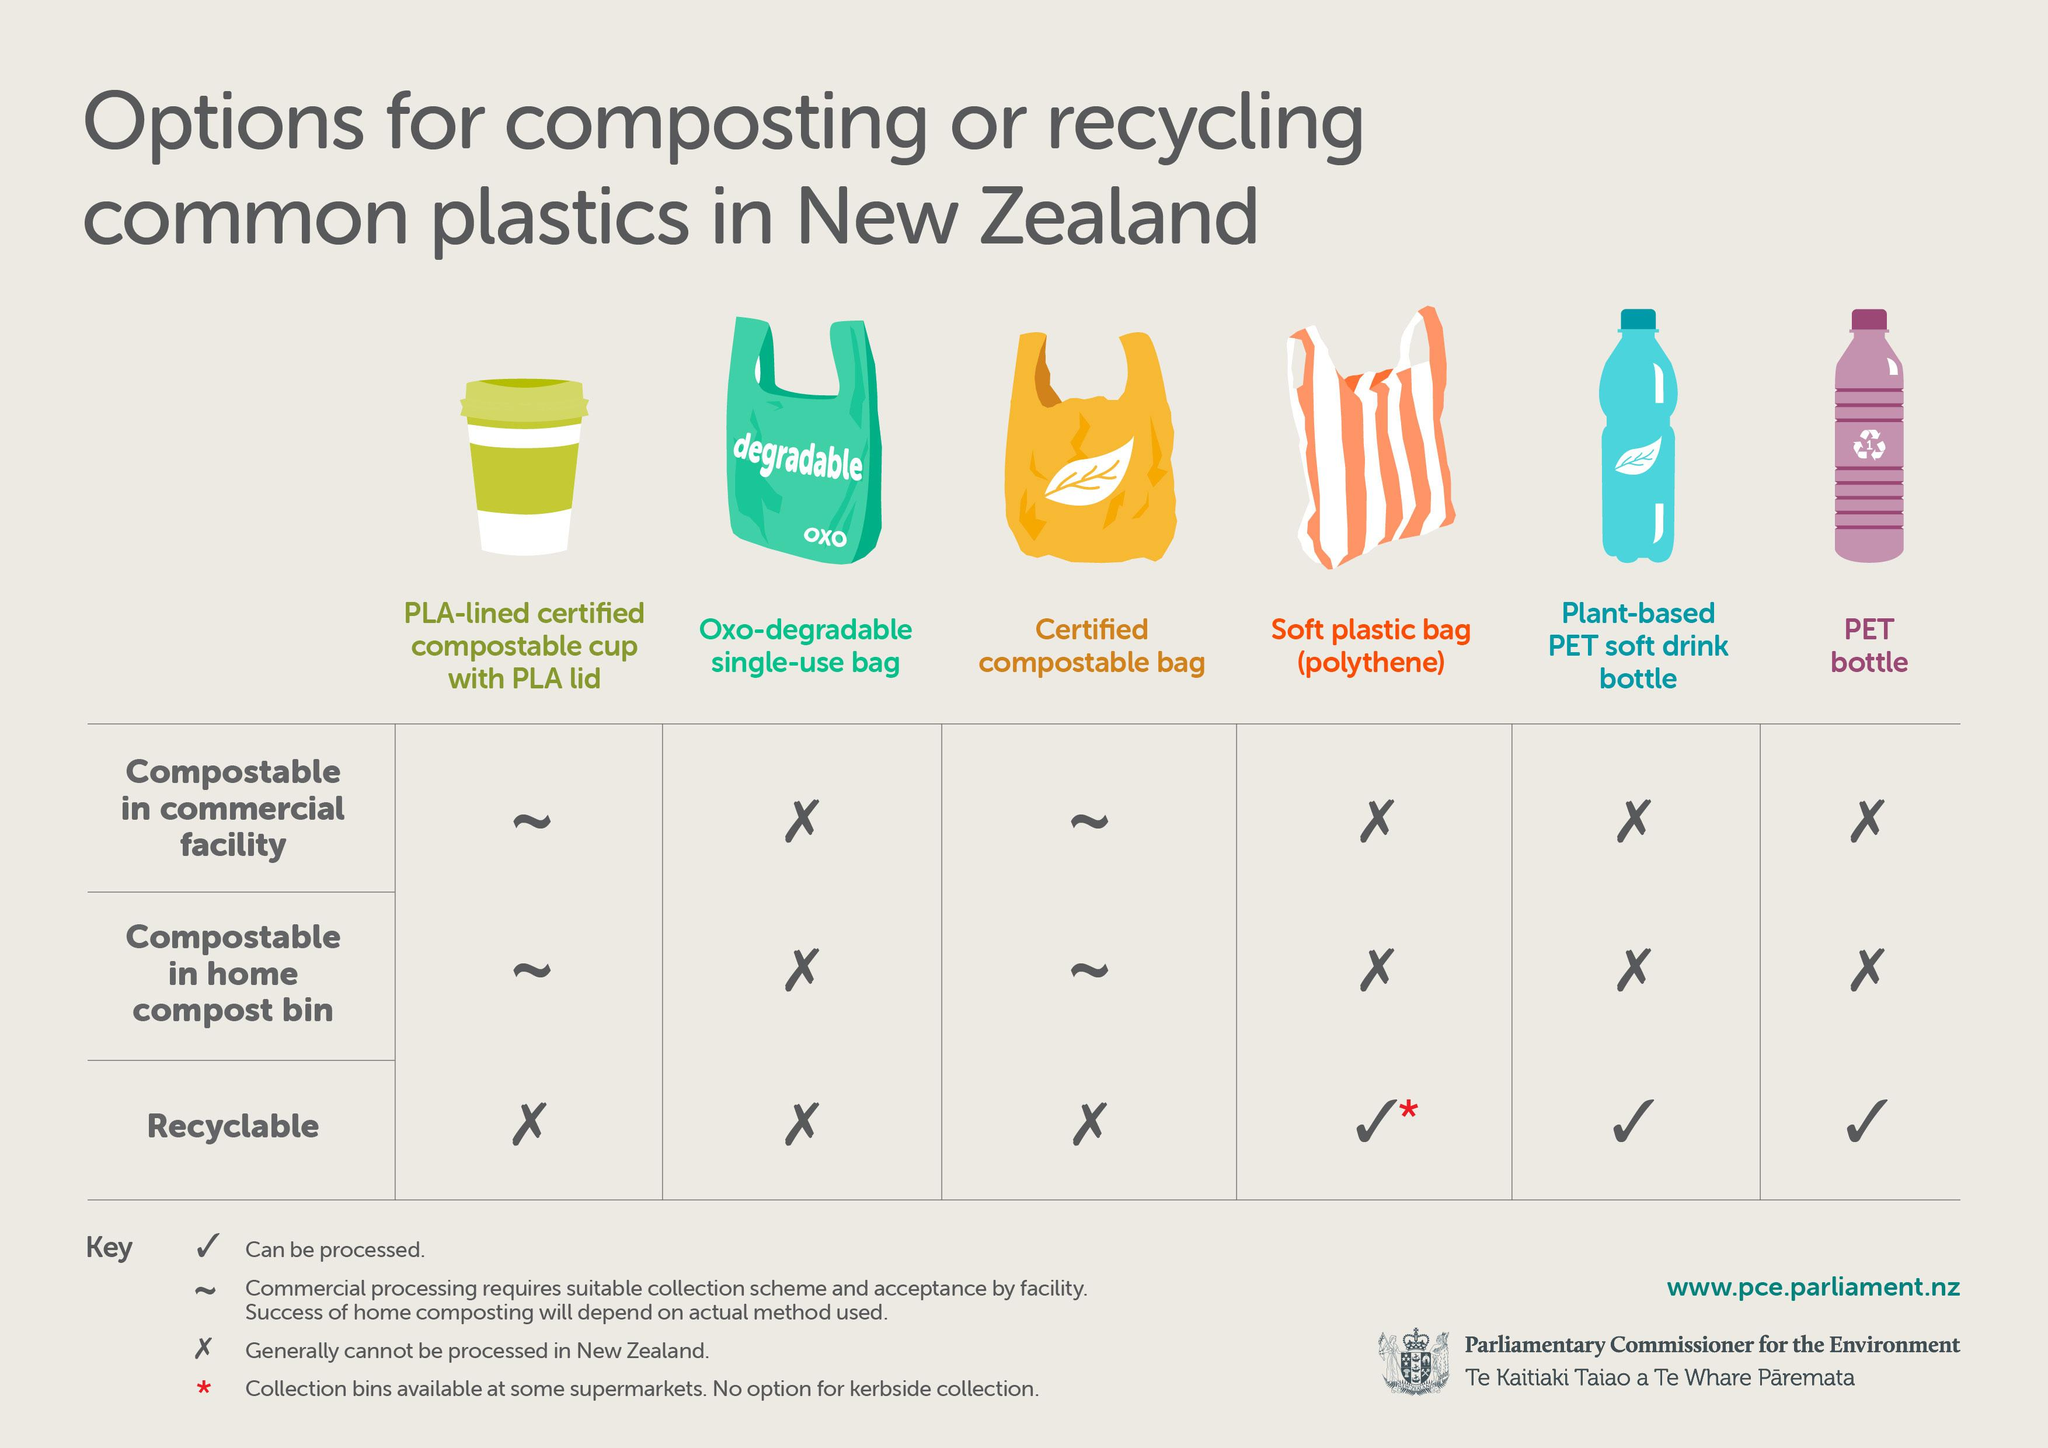List a handful of essential elements in this visual. This image contains one image of a plastic cup. It is clear that the images displayed show three plastic bags. Plastics can be composted in both commercial facilities and home compost bins. There are four table keys mentioned in this text. Two images of plastic bottles are displayed. 